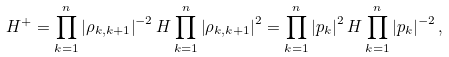<formula> <loc_0><loc_0><loc_500><loc_500>H ^ { + } = \prod _ { k = 1 } ^ { n } \left | \rho _ { k , k + 1 } \right | ^ { - 2 } H \prod _ { k = 1 } ^ { n } \left | \rho _ { k , k + 1 } \right | ^ { 2 } = \prod _ { k = 1 } ^ { n } \left | p _ { k } \right | ^ { 2 } H \prod _ { k = 1 } ^ { n } \left | p _ { k } \right | ^ { - 2 } ,</formula> 